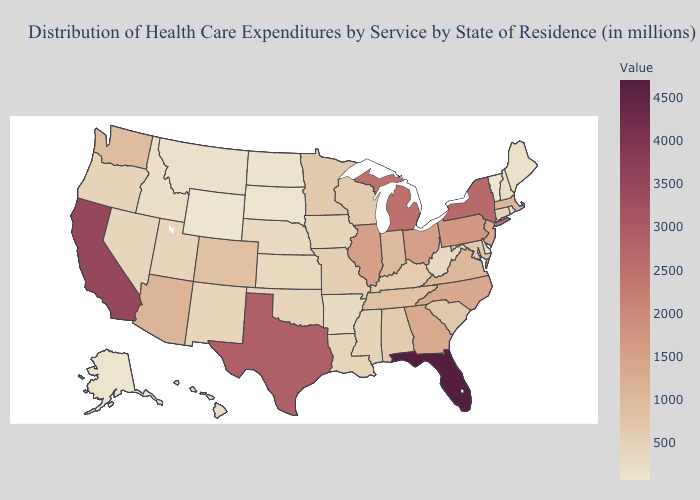Does California have the lowest value in the West?
Write a very short answer. No. Does the map have missing data?
Short answer required. No. Among the states that border Georgia , does Alabama have the lowest value?
Quick response, please. Yes. Does Massachusetts have a lower value than Iowa?
Give a very brief answer. No. Which states have the lowest value in the USA?
Keep it brief. Wyoming. Does Idaho have the highest value in the West?
Be succinct. No. 